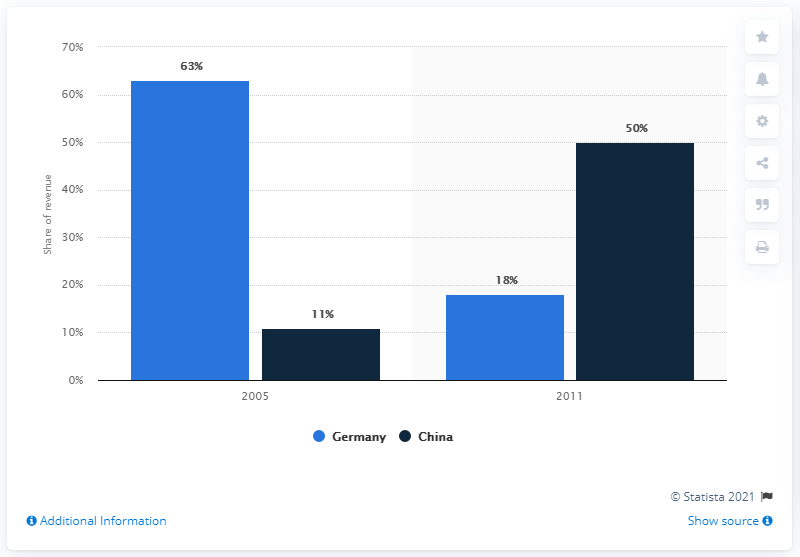Indicate a few pertinent items in this graphic. The data indicates that in 2005, 63% of a particular country was able to be identified as Germany. From 2005 to 2011, China's revenue increased. 